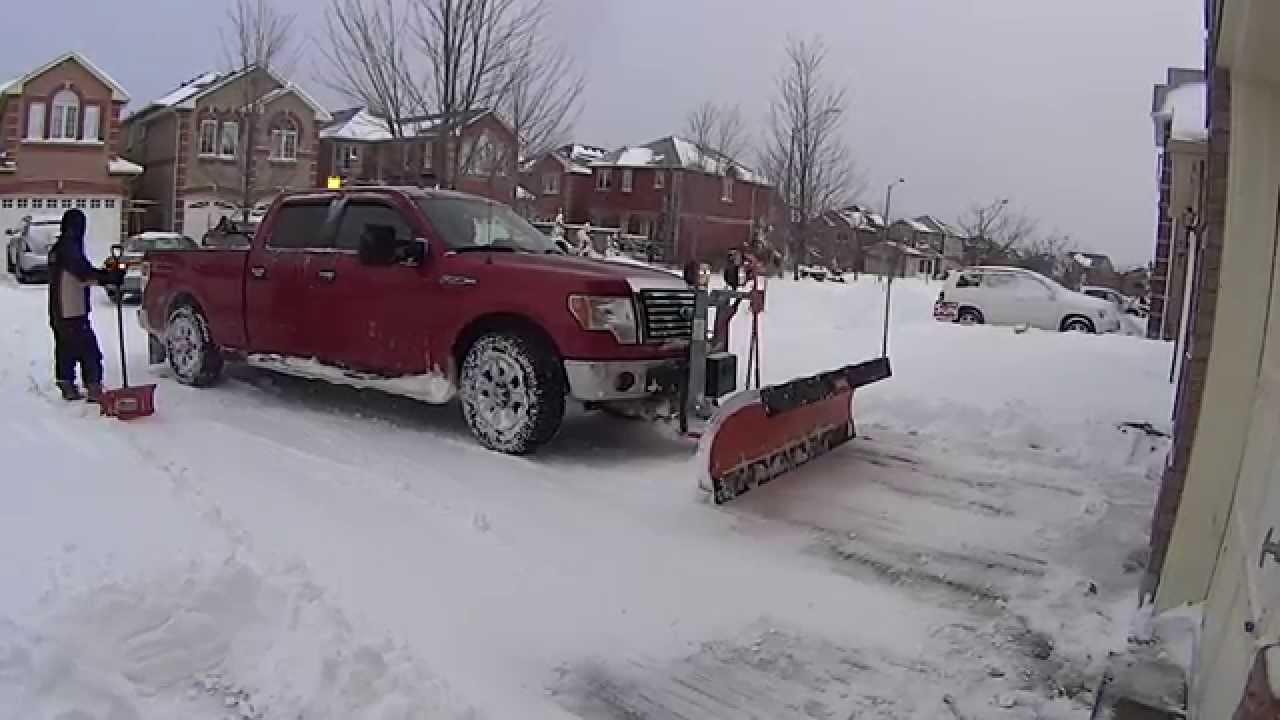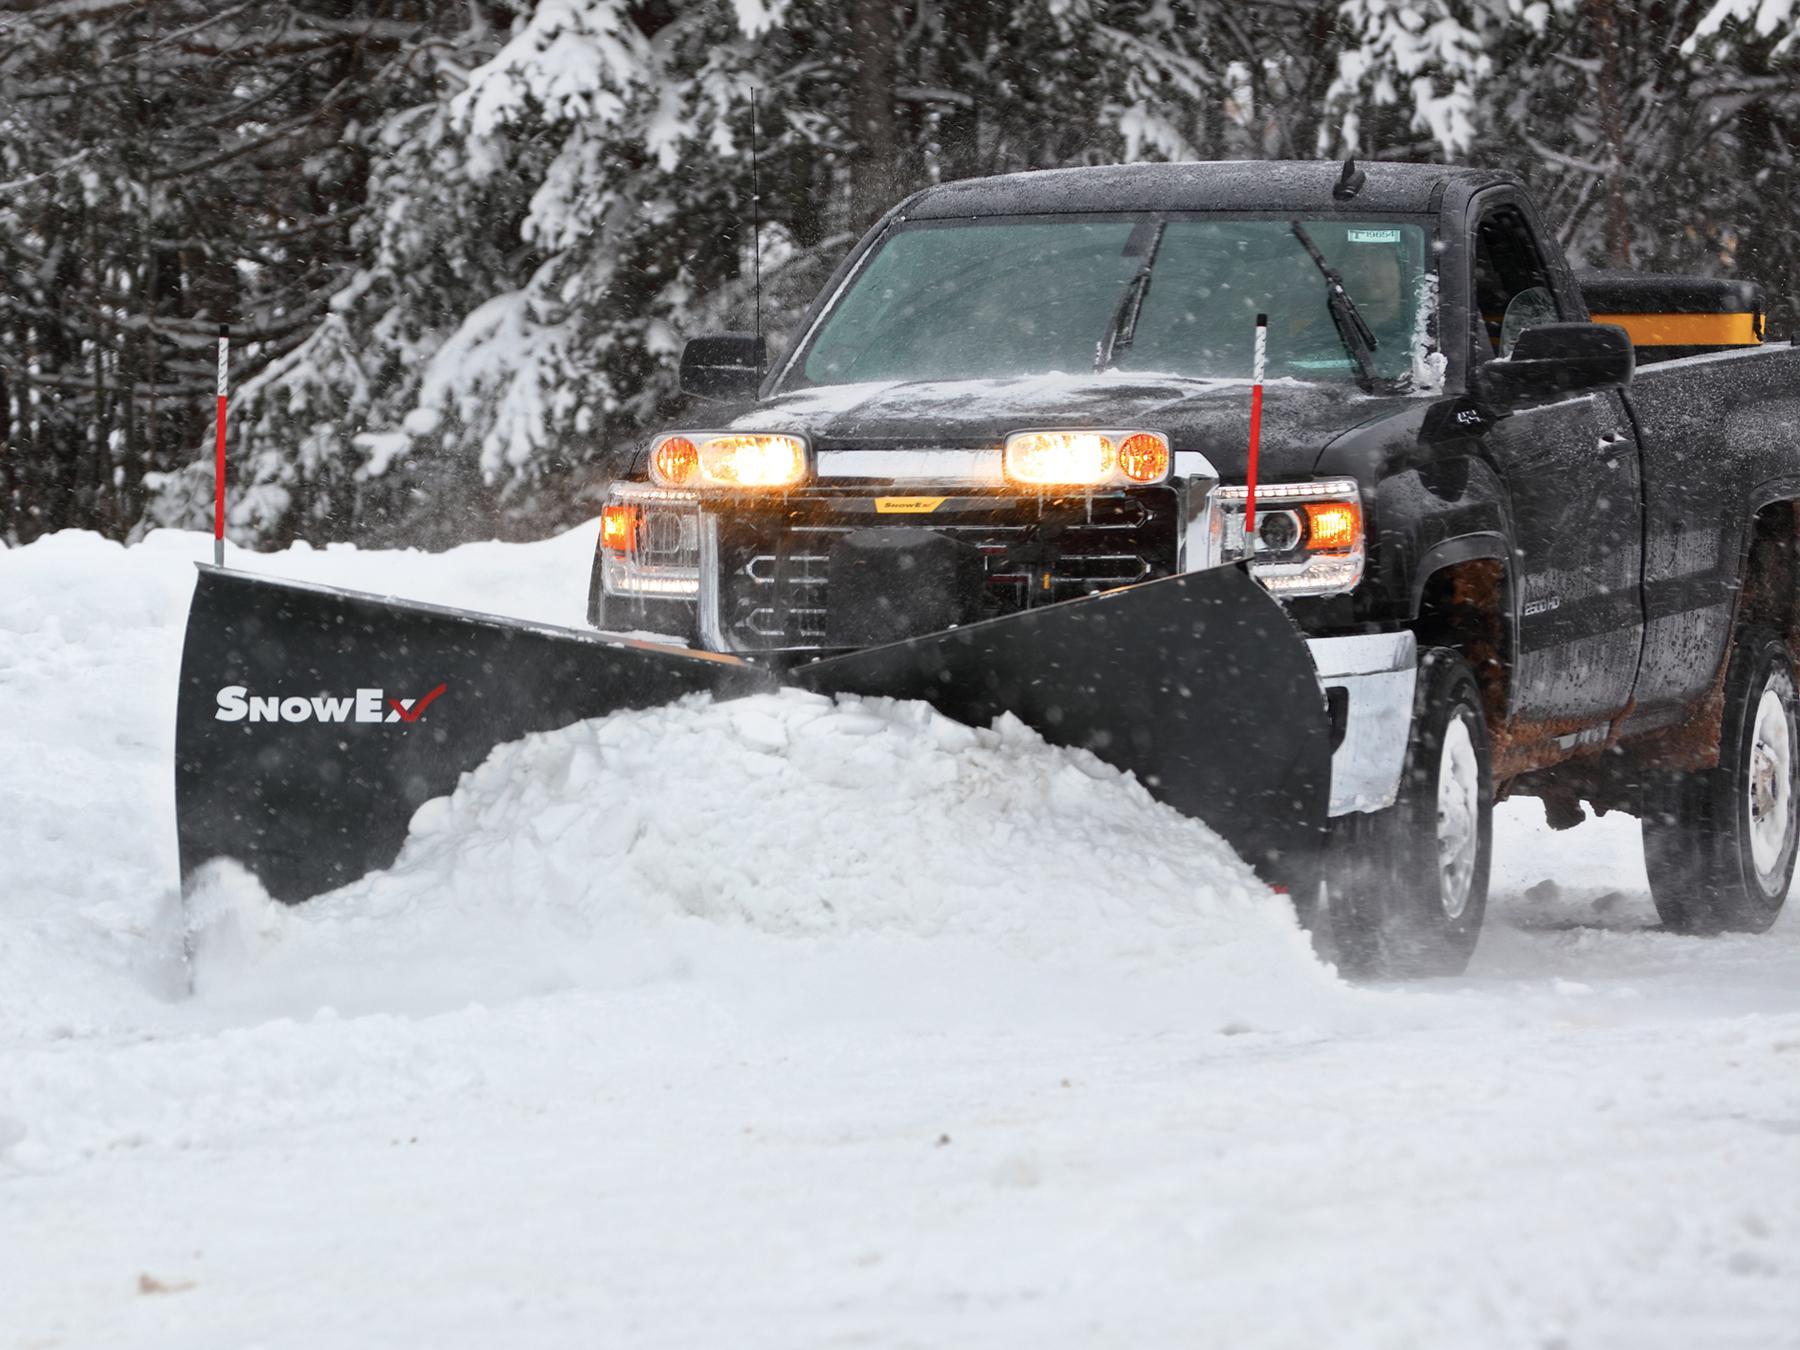The first image is the image on the left, the second image is the image on the right. Assess this claim about the two images: "A red truck pushes a plow through the snow in each of the images.". Correct or not? Answer yes or no. No. The first image is the image on the left, the second image is the image on the right. For the images displayed, is the sentence "One image shows a non-red pickup truck pushing a large mound of snow with a plow." factually correct? Answer yes or no. Yes. 